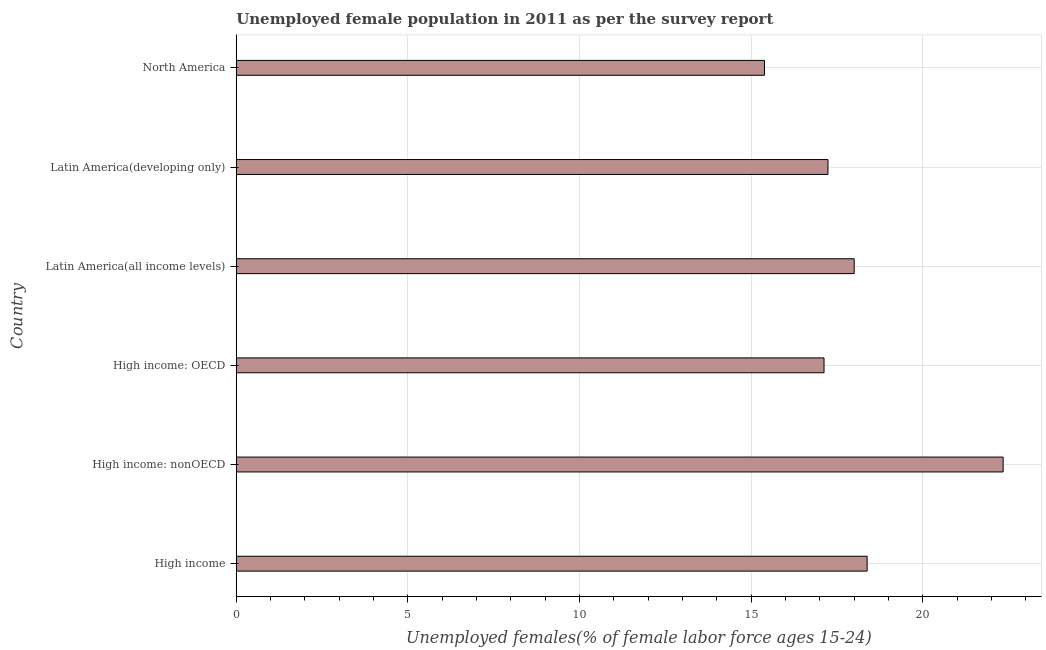Does the graph contain grids?
Offer a very short reply. Yes. What is the title of the graph?
Your response must be concise. Unemployed female population in 2011 as per the survey report. What is the label or title of the X-axis?
Your answer should be very brief. Unemployed females(% of female labor force ages 15-24). What is the unemployed female youth in High income: nonOECD?
Your response must be concise. 22.34. Across all countries, what is the maximum unemployed female youth?
Keep it short and to the point. 22.34. Across all countries, what is the minimum unemployed female youth?
Your answer should be very brief. 15.39. In which country was the unemployed female youth maximum?
Ensure brevity in your answer.  High income: nonOECD. What is the sum of the unemployed female youth?
Offer a terse response. 108.45. What is the difference between the unemployed female youth in High income and Latin America(all income levels)?
Ensure brevity in your answer.  0.38. What is the average unemployed female youth per country?
Your answer should be compact. 18.07. What is the median unemployed female youth?
Make the answer very short. 17.62. In how many countries, is the unemployed female youth greater than 5 %?
Offer a very short reply. 6. What is the ratio of the unemployed female youth in High income: nonOECD to that in Latin America(all income levels)?
Offer a very short reply. 1.24. Is the unemployed female youth in High income less than that in North America?
Provide a succinct answer. No. Is the difference between the unemployed female youth in High income and North America greater than the difference between any two countries?
Provide a succinct answer. No. What is the difference between the highest and the second highest unemployed female youth?
Your answer should be compact. 3.96. Is the sum of the unemployed female youth in Latin America(all income levels) and North America greater than the maximum unemployed female youth across all countries?
Make the answer very short. Yes. What is the difference between the highest and the lowest unemployed female youth?
Make the answer very short. 6.95. Are all the bars in the graph horizontal?
Provide a succinct answer. Yes. How many countries are there in the graph?
Give a very brief answer. 6. What is the difference between two consecutive major ticks on the X-axis?
Your answer should be compact. 5. What is the Unemployed females(% of female labor force ages 15-24) of High income?
Offer a terse response. 18.38. What is the Unemployed females(% of female labor force ages 15-24) of High income: nonOECD?
Make the answer very short. 22.34. What is the Unemployed females(% of female labor force ages 15-24) in High income: OECD?
Your answer should be very brief. 17.12. What is the Unemployed females(% of female labor force ages 15-24) of Latin America(all income levels)?
Your response must be concise. 18. What is the Unemployed females(% of female labor force ages 15-24) of Latin America(developing only)?
Provide a succinct answer. 17.23. What is the Unemployed females(% of female labor force ages 15-24) of North America?
Your response must be concise. 15.39. What is the difference between the Unemployed females(% of female labor force ages 15-24) in High income and High income: nonOECD?
Keep it short and to the point. -3.96. What is the difference between the Unemployed females(% of female labor force ages 15-24) in High income and High income: OECD?
Your answer should be very brief. 1.26. What is the difference between the Unemployed females(% of female labor force ages 15-24) in High income and Latin America(all income levels)?
Give a very brief answer. 0.38. What is the difference between the Unemployed females(% of female labor force ages 15-24) in High income and Latin America(developing only)?
Ensure brevity in your answer.  1.14. What is the difference between the Unemployed females(% of female labor force ages 15-24) in High income and North America?
Provide a succinct answer. 2.99. What is the difference between the Unemployed females(% of female labor force ages 15-24) in High income: nonOECD and High income: OECD?
Offer a very short reply. 5.22. What is the difference between the Unemployed females(% of female labor force ages 15-24) in High income: nonOECD and Latin America(all income levels)?
Make the answer very short. 4.34. What is the difference between the Unemployed females(% of female labor force ages 15-24) in High income: nonOECD and Latin America(developing only)?
Your response must be concise. 5.1. What is the difference between the Unemployed females(% of female labor force ages 15-24) in High income: nonOECD and North America?
Provide a succinct answer. 6.95. What is the difference between the Unemployed females(% of female labor force ages 15-24) in High income: OECD and Latin America(all income levels)?
Offer a very short reply. -0.88. What is the difference between the Unemployed females(% of female labor force ages 15-24) in High income: OECD and Latin America(developing only)?
Offer a very short reply. -0.11. What is the difference between the Unemployed females(% of female labor force ages 15-24) in High income: OECD and North America?
Your response must be concise. 1.73. What is the difference between the Unemployed females(% of female labor force ages 15-24) in Latin America(all income levels) and Latin America(developing only)?
Offer a terse response. 0.76. What is the difference between the Unemployed females(% of female labor force ages 15-24) in Latin America(all income levels) and North America?
Ensure brevity in your answer.  2.61. What is the difference between the Unemployed females(% of female labor force ages 15-24) in Latin America(developing only) and North America?
Offer a very short reply. 1.85. What is the ratio of the Unemployed females(% of female labor force ages 15-24) in High income to that in High income: nonOECD?
Provide a short and direct response. 0.82. What is the ratio of the Unemployed females(% of female labor force ages 15-24) in High income to that in High income: OECD?
Provide a succinct answer. 1.07. What is the ratio of the Unemployed females(% of female labor force ages 15-24) in High income to that in Latin America(developing only)?
Ensure brevity in your answer.  1.07. What is the ratio of the Unemployed females(% of female labor force ages 15-24) in High income to that in North America?
Offer a terse response. 1.19. What is the ratio of the Unemployed females(% of female labor force ages 15-24) in High income: nonOECD to that in High income: OECD?
Offer a very short reply. 1.3. What is the ratio of the Unemployed females(% of female labor force ages 15-24) in High income: nonOECD to that in Latin America(all income levels)?
Offer a very short reply. 1.24. What is the ratio of the Unemployed females(% of female labor force ages 15-24) in High income: nonOECD to that in Latin America(developing only)?
Keep it short and to the point. 1.3. What is the ratio of the Unemployed females(% of female labor force ages 15-24) in High income: nonOECD to that in North America?
Your response must be concise. 1.45. What is the ratio of the Unemployed females(% of female labor force ages 15-24) in High income: OECD to that in Latin America(all income levels)?
Provide a short and direct response. 0.95. What is the ratio of the Unemployed females(% of female labor force ages 15-24) in High income: OECD to that in Latin America(developing only)?
Your answer should be very brief. 0.99. What is the ratio of the Unemployed females(% of female labor force ages 15-24) in High income: OECD to that in North America?
Give a very brief answer. 1.11. What is the ratio of the Unemployed females(% of female labor force ages 15-24) in Latin America(all income levels) to that in Latin America(developing only)?
Give a very brief answer. 1.04. What is the ratio of the Unemployed females(% of female labor force ages 15-24) in Latin America(all income levels) to that in North America?
Provide a short and direct response. 1.17. What is the ratio of the Unemployed females(% of female labor force ages 15-24) in Latin America(developing only) to that in North America?
Provide a short and direct response. 1.12. 